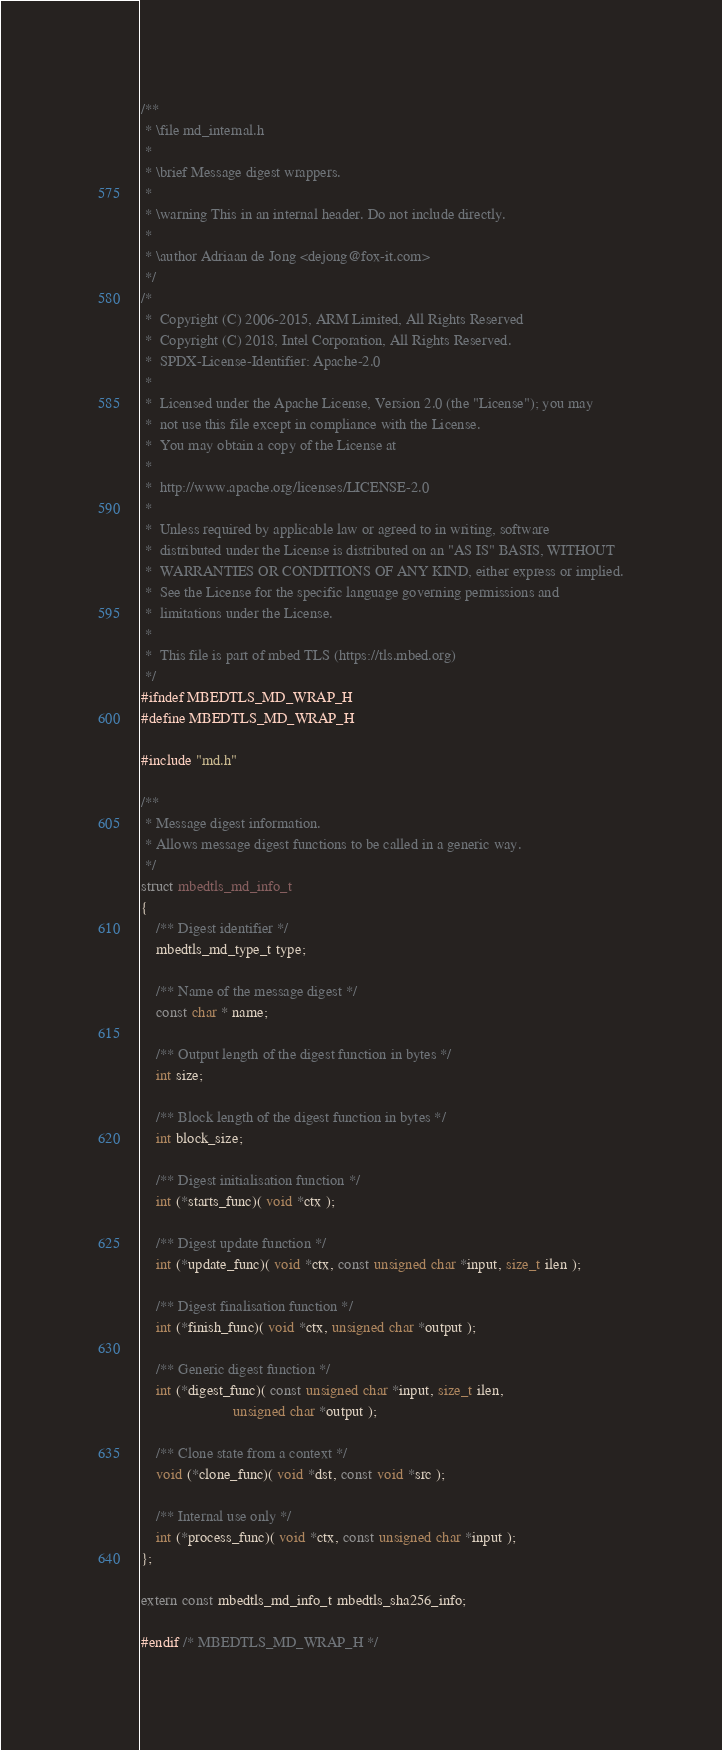<code> <loc_0><loc_0><loc_500><loc_500><_C_>/**
 * \file md_internal.h
 *
 * \brief Message digest wrappers.
 *
 * \warning This in an internal header. Do not include directly.
 *
 * \author Adriaan de Jong <dejong@fox-it.com>
 */
/*
 *  Copyright (C) 2006-2015, ARM Limited, All Rights Reserved
 *  Copyright (C) 2018, Intel Corporation, All Rights Reserved.
 *  SPDX-License-Identifier: Apache-2.0
 *
 *  Licensed under the Apache License, Version 2.0 (the "License"); you may
 *  not use this file except in compliance with the License.
 *  You may obtain a copy of the License at
 *
 *  http://www.apache.org/licenses/LICENSE-2.0
 *
 *  Unless required by applicable law or agreed to in writing, software
 *  distributed under the License is distributed on an "AS IS" BASIS, WITHOUT
 *  WARRANTIES OR CONDITIONS OF ANY KIND, either express or implied.
 *  See the License for the specific language governing permissions and
 *  limitations under the License.
 *
 *  This file is part of mbed TLS (https://tls.mbed.org)
 */
#ifndef MBEDTLS_MD_WRAP_H
#define MBEDTLS_MD_WRAP_H

#include "md.h"

/**
 * Message digest information.
 * Allows message digest functions to be called in a generic way.
 */
struct mbedtls_md_info_t
{
    /** Digest identifier */
    mbedtls_md_type_t type;

    /** Name of the message digest */
    const char * name;

    /** Output length of the digest function in bytes */
    int size;

    /** Block length of the digest function in bytes */
    int block_size;

    /** Digest initialisation function */
    int (*starts_func)( void *ctx );

    /** Digest update function */
    int (*update_func)( void *ctx, const unsigned char *input, size_t ilen );

    /** Digest finalisation function */
    int (*finish_func)( void *ctx, unsigned char *output );

    /** Generic digest function */
    int (*digest_func)( const unsigned char *input, size_t ilen,
                        unsigned char *output );

    /** Clone state from a context */
    void (*clone_func)( void *dst, const void *src );

    /** Internal use only */
    int (*process_func)( void *ctx, const unsigned char *input );
};

extern const mbedtls_md_info_t mbedtls_sha256_info;

#endif /* MBEDTLS_MD_WRAP_H */
</code> 